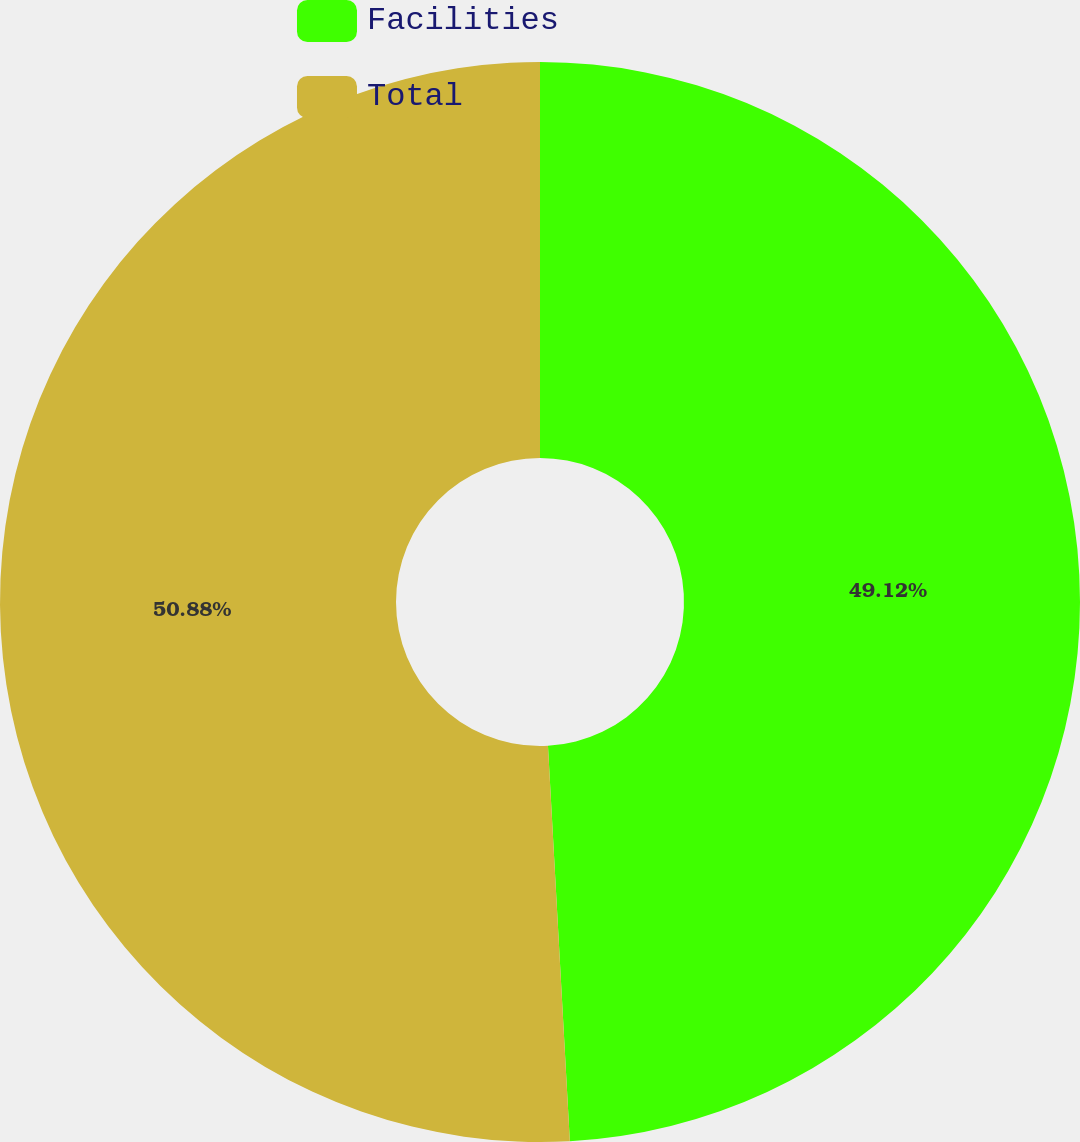Convert chart to OTSL. <chart><loc_0><loc_0><loc_500><loc_500><pie_chart><fcel>Facilities<fcel>Total<nl><fcel>49.12%<fcel>50.88%<nl></chart> 